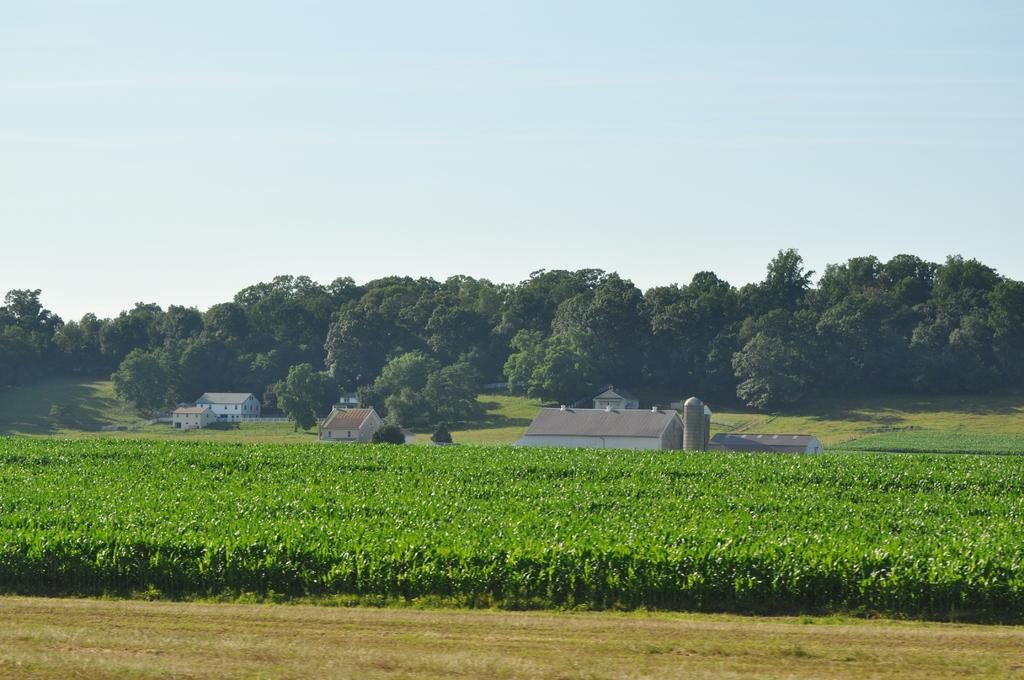What type of vegetation can be seen in the image? There are plants and grass in the image. What can be seen in the background of the image? There are trees, houses, containers, and the sky visible in the background of the image. What type of cherry is growing in the dirt in the image? There is no cherry or dirt present in the image. 